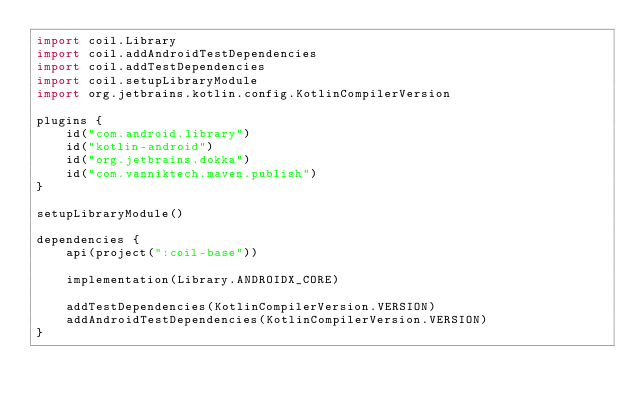Convert code to text. <code><loc_0><loc_0><loc_500><loc_500><_Kotlin_>import coil.Library
import coil.addAndroidTestDependencies
import coil.addTestDependencies
import coil.setupLibraryModule
import org.jetbrains.kotlin.config.KotlinCompilerVersion

plugins {
    id("com.android.library")
    id("kotlin-android")
    id("org.jetbrains.dokka")
    id("com.vanniktech.maven.publish")
}

setupLibraryModule()

dependencies {
    api(project(":coil-base"))

    implementation(Library.ANDROIDX_CORE)

    addTestDependencies(KotlinCompilerVersion.VERSION)
    addAndroidTestDependencies(KotlinCompilerVersion.VERSION)
}
</code> 